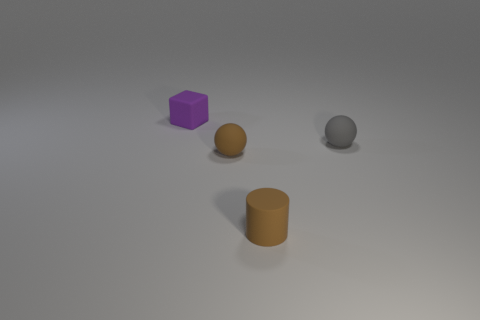Are there fewer purple rubber blocks that are right of the gray object than big matte things?
Offer a very short reply. No. There is a small object that is in front of the brown thing behind the cylinder; what is it made of?
Provide a succinct answer. Rubber. The thing that is on the left side of the small brown matte cylinder and in front of the small gray thing has what shape?
Make the answer very short. Sphere. What number of other objects are there of the same color as the matte block?
Keep it short and to the point. 0. How many objects are either small spheres that are in front of the small gray rubber thing or small purple rubber cubes?
Your answer should be very brief. 2. Is the color of the small rubber cube the same as the small ball that is on the right side of the tiny brown matte cylinder?
Provide a short and direct response. No. There is a ball in front of the object that is right of the brown rubber cylinder; how big is it?
Make the answer very short. Small. How many things are either cubes or small brown things that are on the left side of the tiny brown rubber cylinder?
Your answer should be compact. 2. There is a brown rubber thing on the left side of the brown rubber cylinder; is its shape the same as the small gray rubber thing?
Your response must be concise. Yes. What number of cylinders are on the right side of the matte sphere that is in front of the tiny ball behind the tiny brown ball?
Provide a short and direct response. 1. 